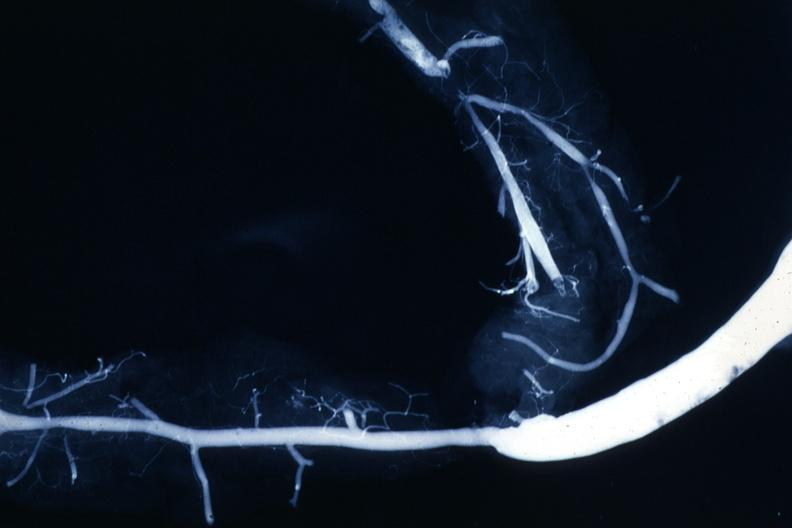what is present?
Answer the question using a single word or phrase. Angiogram saphenous vein bypass graft 